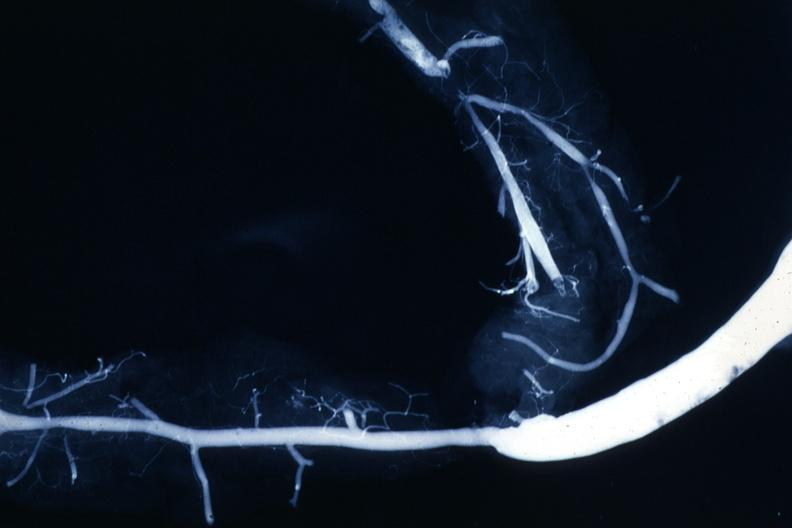what is present?
Answer the question using a single word or phrase. Angiogram saphenous vein bypass graft 